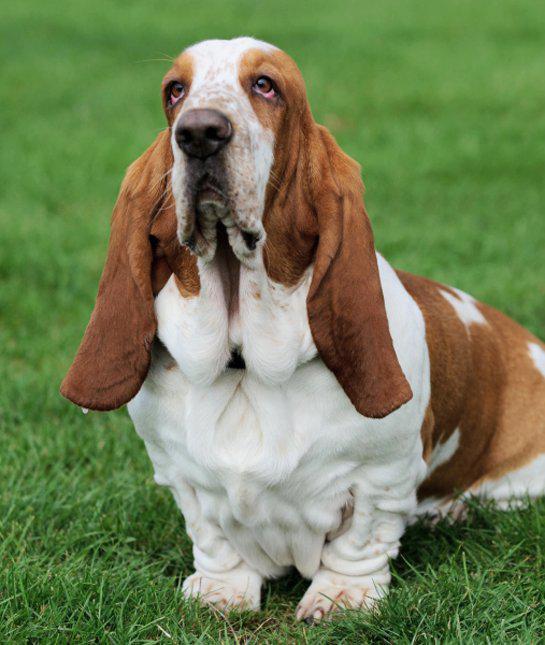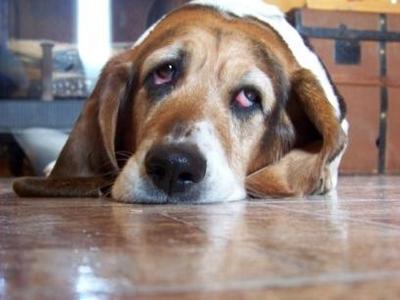The first image is the image on the left, the second image is the image on the right. For the images shown, is this caption "One of the basset hounds is sitting in the grass." true? Answer yes or no. Yes. The first image is the image on the left, the second image is the image on the right. Examine the images to the left and right. Is the description "One image has no less than two dogs in it." accurate? Answer yes or no. No. 